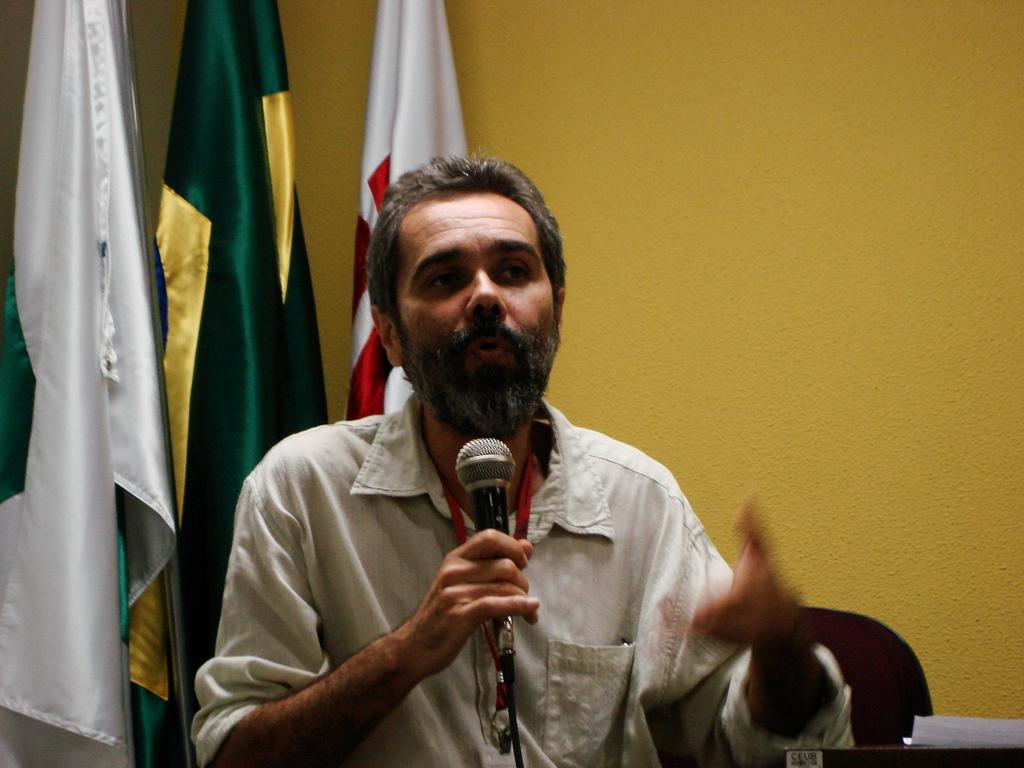Who is the main subject in the image? There is a man in the image. What is the man holding in the image? The man is holding a microphone. What is the man doing in the image? The man is talking. What can be seen in the background of the image? There is a wall and flags in the background of the image. What type of wood can be seen in the image? There is no wood present in the image. What drug is the man taking in the image? There is no drug present in the image, and the man is not taking any drugs. 